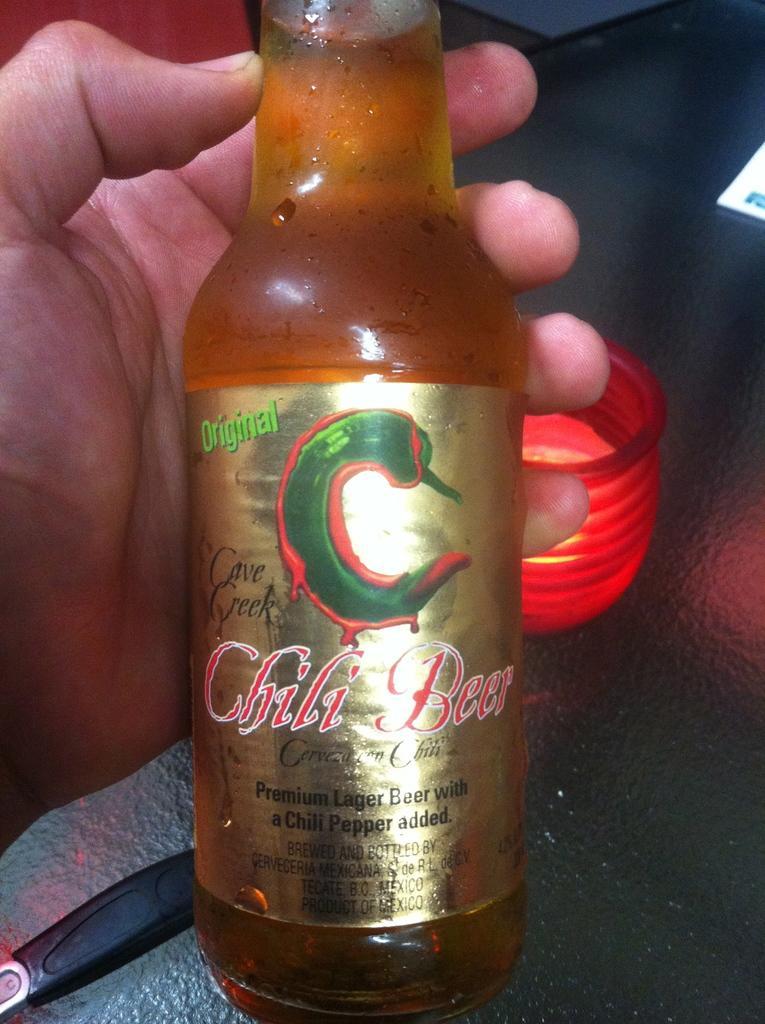In one or two sentences, can you explain what this image depicts? Person is holding a bottle. On this bottle there is a sticker. This is container. 